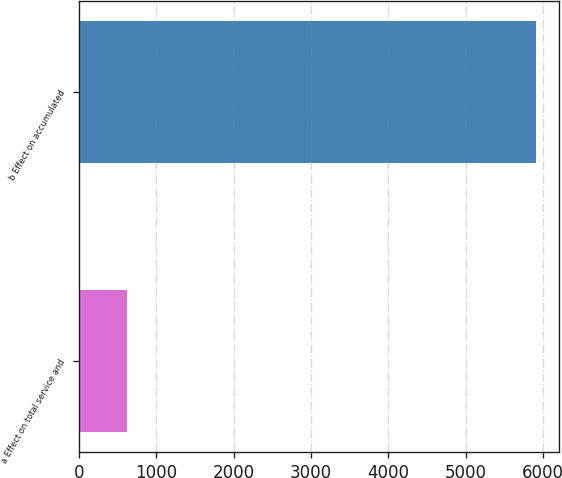<chart> <loc_0><loc_0><loc_500><loc_500><bar_chart><fcel>a Effect on total service and<fcel>b Effect on accumulated<nl><fcel>617<fcel>5905<nl></chart> 